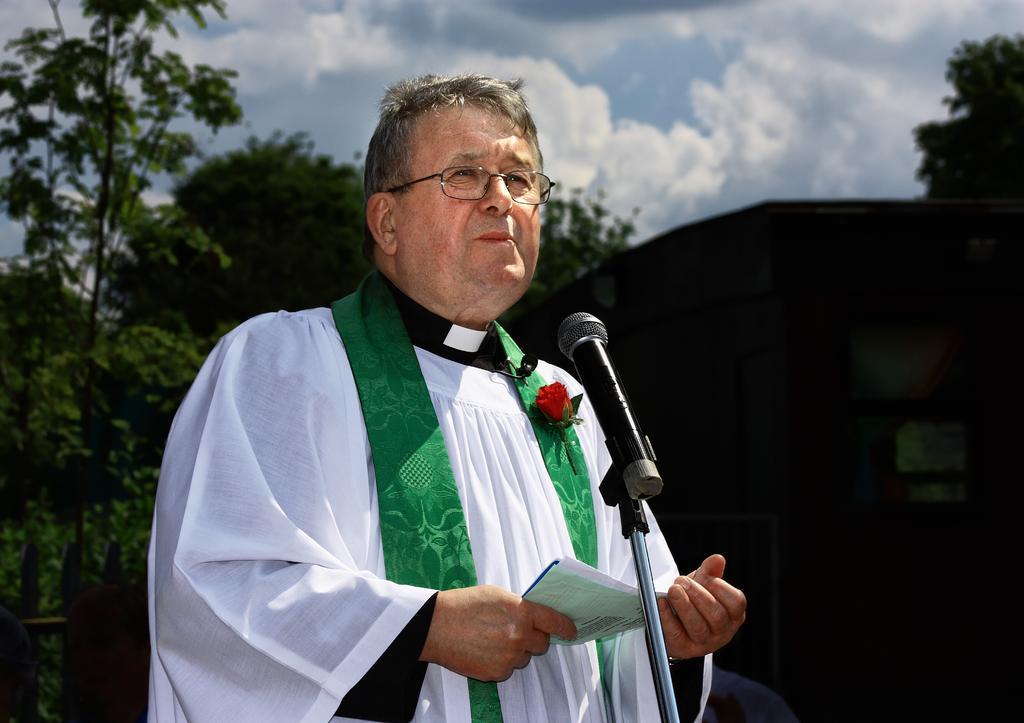How would you summarize this image in a sentence or two? In the middle of the image a man is standing and holding some papers and there is a microphone. Behind him there are some trees. Top of the image there are some clouds and sky. 